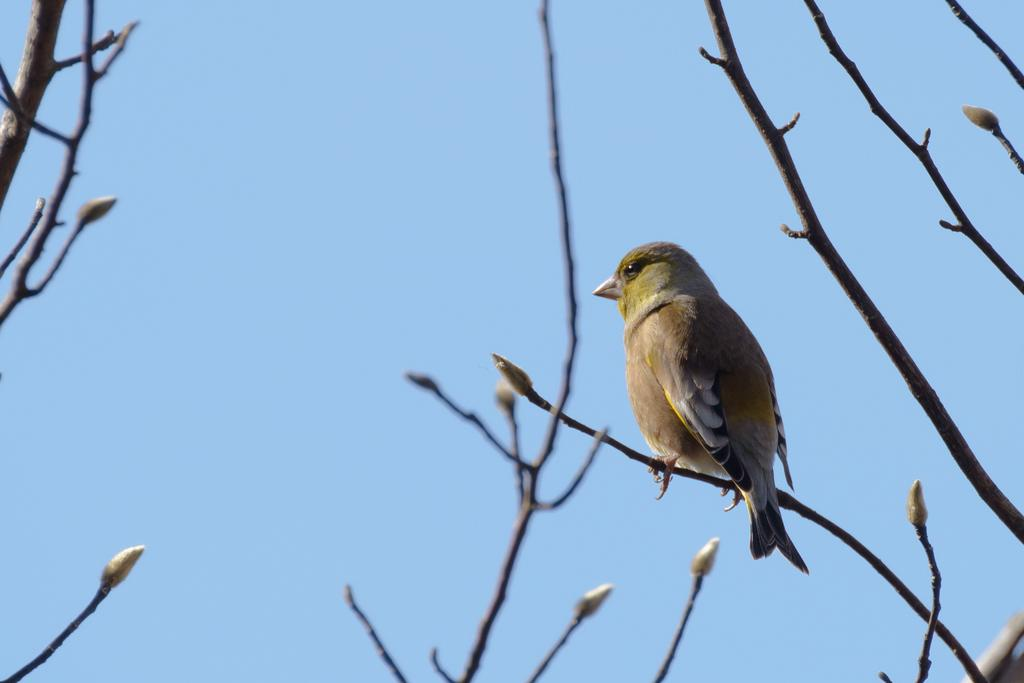What type of animal can be seen in the image? There is a bird in the image. Where is the bird located? The bird is on a stem. What can be seen in the background of the image? There is sky visible in the background of the image. How many eyes can be seen on the loaf in the image? There is no loaf present in the image, so it is not possible to determine the number of eyes on it. 